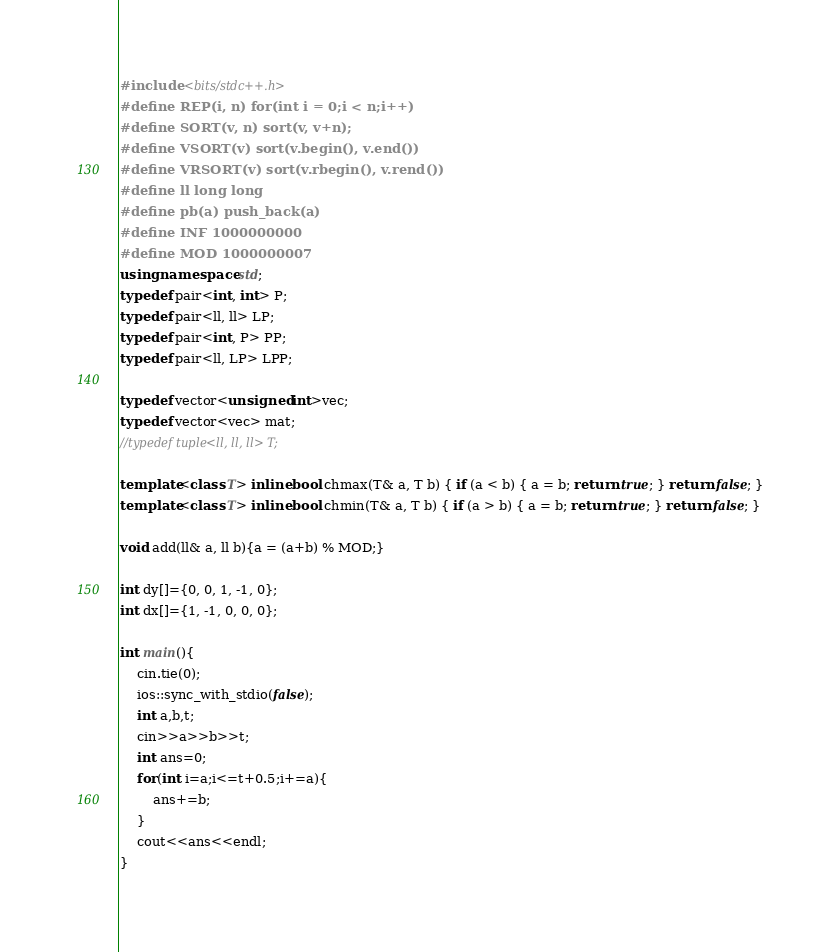<code> <loc_0><loc_0><loc_500><loc_500><_C++_>#include <bits/stdc++.h>
#define REP(i, n) for(int i = 0;i < n;i++)
#define SORT(v, n) sort(v, v+n);
#define VSORT(v) sort(v.begin(), v.end())
#define VRSORT(v) sort(v.rbegin(), v.rend())
#define ll long long
#define pb(a) push_back(a)
#define INF 1000000000
#define MOD 1000000007
using namespace std;
typedef pair<int, int> P;
typedef pair<ll, ll> LP;
typedef pair<int, P> PP;
typedef pair<ll, LP> LPP;

typedef vector<unsigned int>vec;
typedef vector<vec> mat;
//typedef tuple<ll, ll, ll> T;

template<class T> inline bool chmax(T& a, T b) { if (a < b) { a = b; return true; } return false; }
template<class T> inline bool chmin(T& a, T b) { if (a > b) { a = b; return true; } return false; }

void add(ll& a, ll b){a = (a+b) % MOD;}

int dy[]={0, 0, 1, -1, 0};
int dx[]={1, -1, 0, 0, 0};

int main(){
    cin.tie(0);
    ios::sync_with_stdio(false);
    int a,b,t;
    cin>>a>>b>>t;
    int ans=0;
    for(int i=a;i<=t+0.5;i+=a){
        ans+=b;
    }
    cout<<ans<<endl;
}</code> 